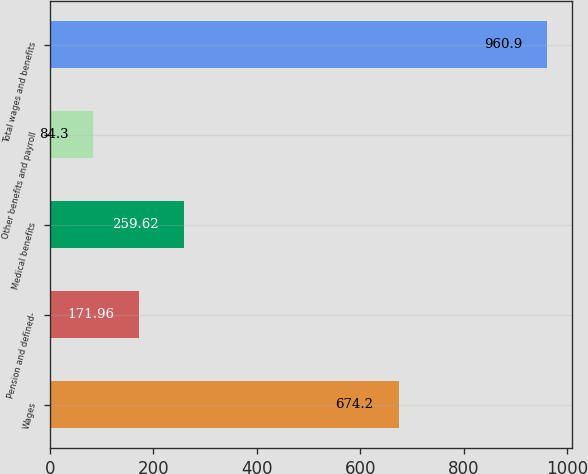Convert chart. <chart><loc_0><loc_0><loc_500><loc_500><bar_chart><fcel>Wages<fcel>Pension and defined-<fcel>Medical benefits<fcel>Other benefits and payroll<fcel>Total wages and benefits<nl><fcel>674.2<fcel>171.96<fcel>259.62<fcel>84.3<fcel>960.9<nl></chart> 